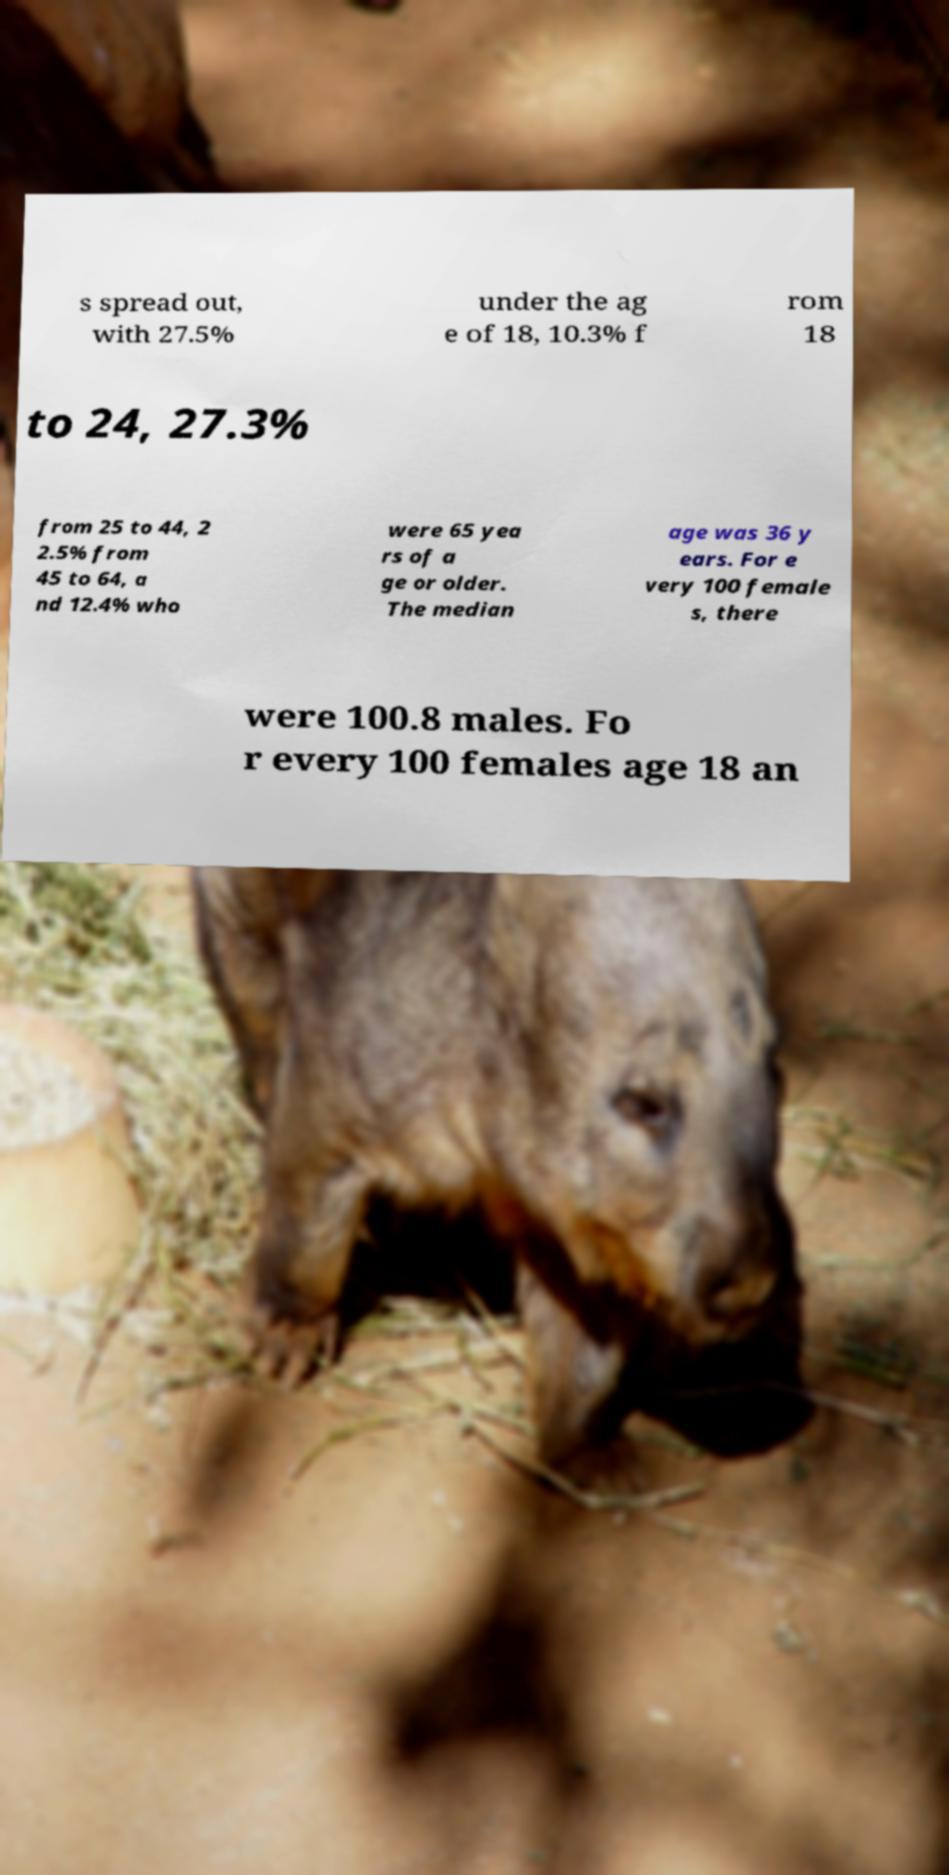There's text embedded in this image that I need extracted. Can you transcribe it verbatim? s spread out, with 27.5% under the ag e of 18, 10.3% f rom 18 to 24, 27.3% from 25 to 44, 2 2.5% from 45 to 64, a nd 12.4% who were 65 yea rs of a ge or older. The median age was 36 y ears. For e very 100 female s, there were 100.8 males. Fo r every 100 females age 18 an 